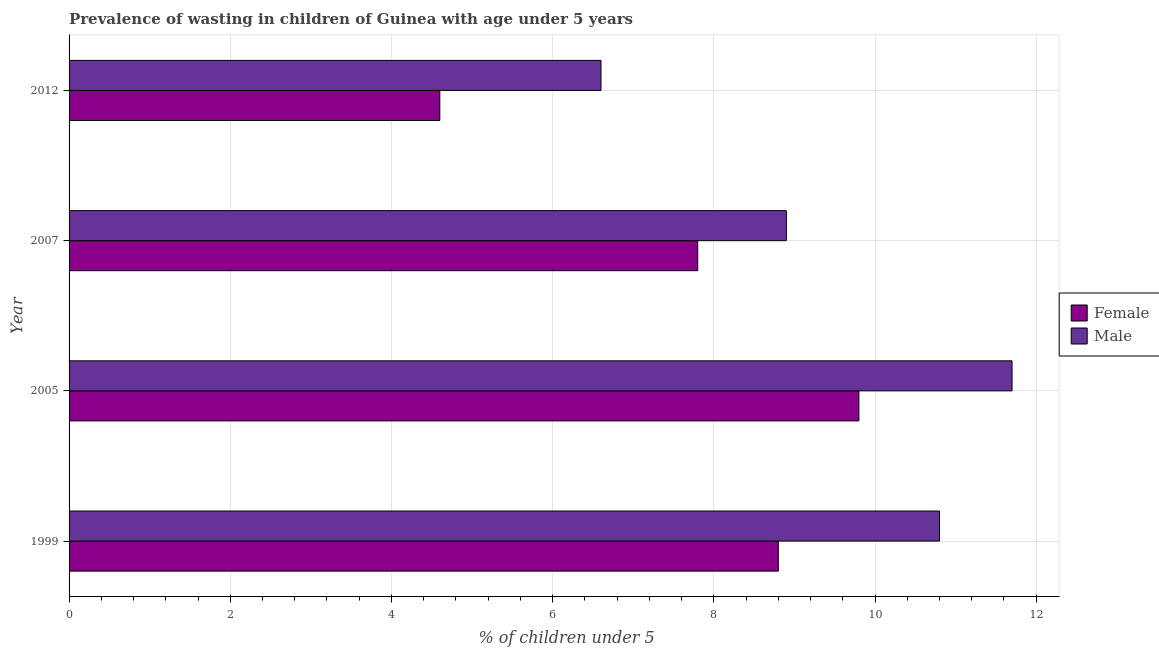How many different coloured bars are there?
Your answer should be very brief. 2. How many groups of bars are there?
Keep it short and to the point. 4. Are the number of bars per tick equal to the number of legend labels?
Provide a succinct answer. Yes. How many bars are there on the 4th tick from the top?
Provide a short and direct response. 2. In how many cases, is the number of bars for a given year not equal to the number of legend labels?
Your answer should be compact. 0. What is the percentage of undernourished female children in 2005?
Give a very brief answer. 9.8. Across all years, what is the maximum percentage of undernourished male children?
Offer a very short reply. 11.7. Across all years, what is the minimum percentage of undernourished female children?
Your answer should be compact. 4.6. What is the total percentage of undernourished female children in the graph?
Offer a terse response. 31. What is the difference between the percentage of undernourished female children in 2005 and the percentage of undernourished male children in 2012?
Your answer should be very brief. 3.2. In the year 2007, what is the difference between the percentage of undernourished male children and percentage of undernourished female children?
Make the answer very short. 1.1. What is the ratio of the percentage of undernourished male children in 1999 to that in 2007?
Your response must be concise. 1.21. Is the percentage of undernourished male children in 1999 less than that in 2012?
Ensure brevity in your answer.  No. Is the difference between the percentage of undernourished female children in 1999 and 2012 greater than the difference between the percentage of undernourished male children in 1999 and 2012?
Offer a very short reply. No. Is the sum of the percentage of undernourished female children in 1999 and 2007 greater than the maximum percentage of undernourished male children across all years?
Your answer should be compact. Yes. What does the 2nd bar from the top in 2012 represents?
Give a very brief answer. Female. What does the 2nd bar from the bottom in 2012 represents?
Provide a succinct answer. Male. How many bars are there?
Your answer should be compact. 8. Are all the bars in the graph horizontal?
Provide a succinct answer. Yes. How many years are there in the graph?
Offer a terse response. 4. How many legend labels are there?
Offer a very short reply. 2. What is the title of the graph?
Keep it short and to the point. Prevalence of wasting in children of Guinea with age under 5 years. What is the label or title of the X-axis?
Your response must be concise.  % of children under 5. What is the label or title of the Y-axis?
Provide a succinct answer. Year. What is the  % of children under 5 in Female in 1999?
Offer a very short reply. 8.8. What is the  % of children under 5 of Male in 1999?
Your answer should be very brief. 10.8. What is the  % of children under 5 in Female in 2005?
Your answer should be very brief. 9.8. What is the  % of children under 5 in Male in 2005?
Keep it short and to the point. 11.7. What is the  % of children under 5 in Female in 2007?
Make the answer very short. 7.8. What is the  % of children under 5 in Male in 2007?
Keep it short and to the point. 8.9. What is the  % of children under 5 of Female in 2012?
Give a very brief answer. 4.6. What is the  % of children under 5 in Male in 2012?
Provide a succinct answer. 6.6. Across all years, what is the maximum  % of children under 5 of Female?
Your answer should be compact. 9.8. Across all years, what is the maximum  % of children under 5 in Male?
Give a very brief answer. 11.7. Across all years, what is the minimum  % of children under 5 of Female?
Your answer should be very brief. 4.6. Across all years, what is the minimum  % of children under 5 of Male?
Your answer should be very brief. 6.6. What is the total  % of children under 5 of Male in the graph?
Provide a succinct answer. 38. What is the difference between the  % of children under 5 in Female in 1999 and that in 2005?
Keep it short and to the point. -1. What is the difference between the  % of children under 5 of Male in 1999 and that in 2007?
Offer a terse response. 1.9. What is the difference between the  % of children under 5 of Male in 1999 and that in 2012?
Keep it short and to the point. 4.2. What is the difference between the  % of children under 5 of Female in 2005 and that in 2007?
Provide a succinct answer. 2. What is the difference between the  % of children under 5 in Male in 2005 and that in 2007?
Ensure brevity in your answer.  2.8. What is the difference between the  % of children under 5 of Male in 2005 and that in 2012?
Give a very brief answer. 5.1. What is the difference between the  % of children under 5 in Female in 2007 and that in 2012?
Ensure brevity in your answer.  3.2. What is the difference between the  % of children under 5 of Male in 2007 and that in 2012?
Your response must be concise. 2.3. What is the difference between the  % of children under 5 of Female in 1999 and the  % of children under 5 of Male in 2005?
Make the answer very short. -2.9. What is the difference between the  % of children under 5 of Female in 1999 and the  % of children under 5 of Male in 2012?
Provide a succinct answer. 2.2. What is the difference between the  % of children under 5 of Female in 2005 and the  % of children under 5 of Male in 2007?
Give a very brief answer. 0.9. What is the difference between the  % of children under 5 in Female in 2005 and the  % of children under 5 in Male in 2012?
Provide a short and direct response. 3.2. What is the average  % of children under 5 in Female per year?
Offer a very short reply. 7.75. In the year 1999, what is the difference between the  % of children under 5 of Female and  % of children under 5 of Male?
Keep it short and to the point. -2. In the year 2007, what is the difference between the  % of children under 5 in Female and  % of children under 5 in Male?
Your answer should be very brief. -1.1. In the year 2012, what is the difference between the  % of children under 5 in Female and  % of children under 5 in Male?
Provide a short and direct response. -2. What is the ratio of the  % of children under 5 in Female in 1999 to that in 2005?
Provide a short and direct response. 0.9. What is the ratio of the  % of children under 5 of Female in 1999 to that in 2007?
Your answer should be very brief. 1.13. What is the ratio of the  % of children under 5 in Male in 1999 to that in 2007?
Offer a terse response. 1.21. What is the ratio of the  % of children under 5 of Female in 1999 to that in 2012?
Your answer should be very brief. 1.91. What is the ratio of the  % of children under 5 in Male in 1999 to that in 2012?
Provide a short and direct response. 1.64. What is the ratio of the  % of children under 5 in Female in 2005 to that in 2007?
Keep it short and to the point. 1.26. What is the ratio of the  % of children under 5 in Male in 2005 to that in 2007?
Offer a very short reply. 1.31. What is the ratio of the  % of children under 5 in Female in 2005 to that in 2012?
Ensure brevity in your answer.  2.13. What is the ratio of the  % of children under 5 of Male in 2005 to that in 2012?
Make the answer very short. 1.77. What is the ratio of the  % of children under 5 in Female in 2007 to that in 2012?
Keep it short and to the point. 1.7. What is the ratio of the  % of children under 5 in Male in 2007 to that in 2012?
Give a very brief answer. 1.35. What is the difference between the highest and the second highest  % of children under 5 in Male?
Give a very brief answer. 0.9. What is the difference between the highest and the lowest  % of children under 5 in Female?
Offer a very short reply. 5.2. What is the difference between the highest and the lowest  % of children under 5 in Male?
Your answer should be very brief. 5.1. 